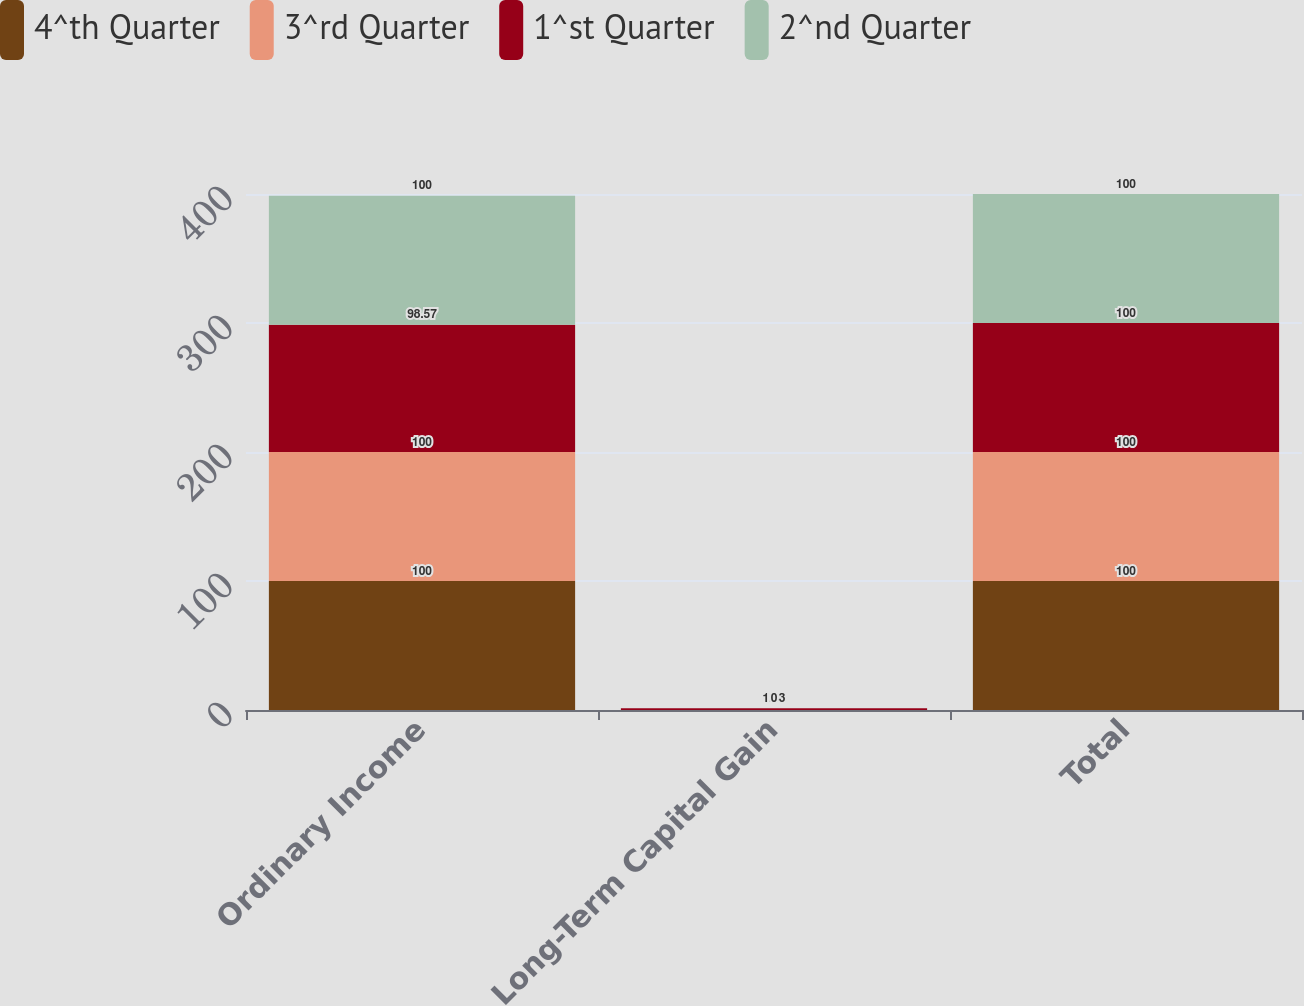<chart> <loc_0><loc_0><loc_500><loc_500><stacked_bar_chart><ecel><fcel>Ordinary Income<fcel>Long-Term Capital Gain<fcel>Total<nl><fcel>4^th Quarter<fcel>100<fcel>0<fcel>100<nl><fcel>3^rd Quarter<fcel>100<fcel>0<fcel>100<nl><fcel>1^st Quarter<fcel>98.57<fcel>1.43<fcel>100<nl><fcel>2^nd Quarter<fcel>100<fcel>0<fcel>100<nl></chart> 